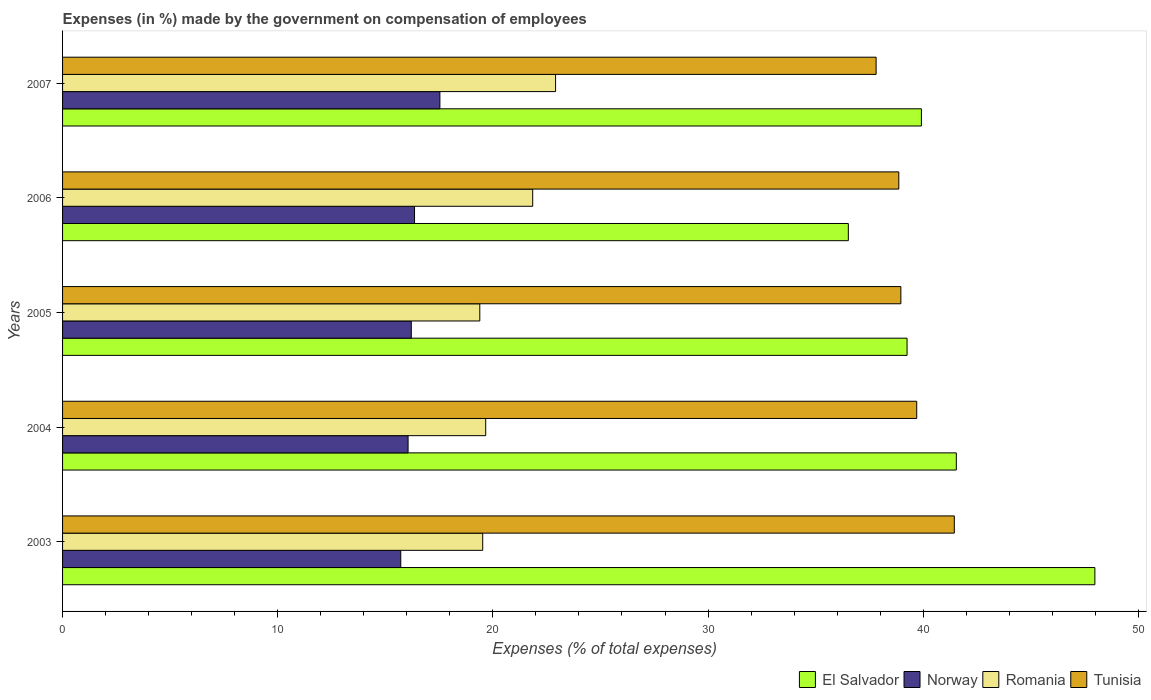Are the number of bars per tick equal to the number of legend labels?
Your answer should be compact. Yes. Are the number of bars on each tick of the Y-axis equal?
Offer a terse response. Yes. What is the percentage of expenses made by the government on compensation of employees in Norway in 2007?
Offer a very short reply. 17.54. Across all years, what is the maximum percentage of expenses made by the government on compensation of employees in Romania?
Make the answer very short. 22.91. Across all years, what is the minimum percentage of expenses made by the government on compensation of employees in El Salvador?
Give a very brief answer. 36.52. What is the total percentage of expenses made by the government on compensation of employees in Tunisia in the graph?
Provide a short and direct response. 196.78. What is the difference between the percentage of expenses made by the government on compensation of employees in Tunisia in 2003 and that in 2007?
Ensure brevity in your answer.  3.63. What is the difference between the percentage of expenses made by the government on compensation of employees in El Salvador in 2007 and the percentage of expenses made by the government on compensation of employees in Romania in 2003?
Your answer should be very brief. 20.39. What is the average percentage of expenses made by the government on compensation of employees in Tunisia per year?
Your answer should be compact. 39.36. In the year 2007, what is the difference between the percentage of expenses made by the government on compensation of employees in Romania and percentage of expenses made by the government on compensation of employees in Tunisia?
Keep it short and to the point. -14.9. In how many years, is the percentage of expenses made by the government on compensation of employees in El Salvador greater than 20 %?
Your answer should be compact. 5. What is the ratio of the percentage of expenses made by the government on compensation of employees in El Salvador in 2003 to that in 2006?
Give a very brief answer. 1.31. Is the difference between the percentage of expenses made by the government on compensation of employees in Romania in 2003 and 2007 greater than the difference between the percentage of expenses made by the government on compensation of employees in Tunisia in 2003 and 2007?
Make the answer very short. No. What is the difference between the highest and the second highest percentage of expenses made by the government on compensation of employees in Romania?
Your response must be concise. 1.06. What is the difference between the highest and the lowest percentage of expenses made by the government on compensation of employees in Romania?
Your response must be concise. 3.52. Is the sum of the percentage of expenses made by the government on compensation of employees in El Salvador in 2004 and 2007 greater than the maximum percentage of expenses made by the government on compensation of employees in Tunisia across all years?
Your response must be concise. Yes. What does the 1st bar from the top in 2003 represents?
Your answer should be compact. Tunisia. What does the 4th bar from the bottom in 2007 represents?
Offer a very short reply. Tunisia. Are the values on the major ticks of X-axis written in scientific E-notation?
Your answer should be very brief. No. Does the graph contain any zero values?
Provide a succinct answer. No. Does the graph contain grids?
Provide a succinct answer. No. Where does the legend appear in the graph?
Provide a succinct answer. Bottom right. How are the legend labels stacked?
Provide a succinct answer. Horizontal. What is the title of the graph?
Keep it short and to the point. Expenses (in %) made by the government on compensation of employees. What is the label or title of the X-axis?
Make the answer very short. Expenses (% of total expenses). What is the Expenses (% of total expenses) in El Salvador in 2003?
Your answer should be compact. 47.98. What is the Expenses (% of total expenses) of Norway in 2003?
Offer a terse response. 15.72. What is the Expenses (% of total expenses) of Romania in 2003?
Offer a very short reply. 19.53. What is the Expenses (% of total expenses) of Tunisia in 2003?
Make the answer very short. 41.44. What is the Expenses (% of total expenses) in El Salvador in 2004?
Your answer should be compact. 41.54. What is the Expenses (% of total expenses) of Norway in 2004?
Your answer should be very brief. 16.06. What is the Expenses (% of total expenses) of Romania in 2004?
Offer a very short reply. 19.67. What is the Expenses (% of total expenses) in Tunisia in 2004?
Make the answer very short. 39.7. What is the Expenses (% of total expenses) in El Salvador in 2005?
Provide a succinct answer. 39.25. What is the Expenses (% of total expenses) of Norway in 2005?
Ensure brevity in your answer.  16.21. What is the Expenses (% of total expenses) in Romania in 2005?
Your answer should be very brief. 19.39. What is the Expenses (% of total expenses) of Tunisia in 2005?
Your answer should be very brief. 38.96. What is the Expenses (% of total expenses) in El Salvador in 2006?
Offer a terse response. 36.52. What is the Expenses (% of total expenses) of Norway in 2006?
Keep it short and to the point. 16.36. What is the Expenses (% of total expenses) in Romania in 2006?
Keep it short and to the point. 21.85. What is the Expenses (% of total expenses) in Tunisia in 2006?
Your answer should be compact. 38.86. What is the Expenses (% of total expenses) in El Salvador in 2007?
Provide a short and direct response. 39.92. What is the Expenses (% of total expenses) of Norway in 2007?
Ensure brevity in your answer.  17.54. What is the Expenses (% of total expenses) of Romania in 2007?
Your answer should be compact. 22.91. What is the Expenses (% of total expenses) of Tunisia in 2007?
Make the answer very short. 37.81. Across all years, what is the maximum Expenses (% of total expenses) in El Salvador?
Keep it short and to the point. 47.98. Across all years, what is the maximum Expenses (% of total expenses) in Norway?
Offer a terse response. 17.54. Across all years, what is the maximum Expenses (% of total expenses) in Romania?
Your answer should be compact. 22.91. Across all years, what is the maximum Expenses (% of total expenses) in Tunisia?
Provide a short and direct response. 41.44. Across all years, what is the minimum Expenses (% of total expenses) of El Salvador?
Your answer should be compact. 36.52. Across all years, what is the minimum Expenses (% of total expenses) in Norway?
Provide a succinct answer. 15.72. Across all years, what is the minimum Expenses (% of total expenses) in Romania?
Keep it short and to the point. 19.39. Across all years, what is the minimum Expenses (% of total expenses) of Tunisia?
Provide a succinct answer. 37.81. What is the total Expenses (% of total expenses) in El Salvador in the graph?
Your answer should be very brief. 205.2. What is the total Expenses (% of total expenses) in Norway in the graph?
Provide a short and direct response. 81.88. What is the total Expenses (% of total expenses) of Romania in the graph?
Your answer should be compact. 103.35. What is the total Expenses (% of total expenses) of Tunisia in the graph?
Make the answer very short. 196.78. What is the difference between the Expenses (% of total expenses) of El Salvador in 2003 and that in 2004?
Your answer should be compact. 6.44. What is the difference between the Expenses (% of total expenses) of Norway in 2003 and that in 2004?
Offer a terse response. -0.34. What is the difference between the Expenses (% of total expenses) of Romania in 2003 and that in 2004?
Give a very brief answer. -0.14. What is the difference between the Expenses (% of total expenses) in Tunisia in 2003 and that in 2004?
Make the answer very short. 1.75. What is the difference between the Expenses (% of total expenses) of El Salvador in 2003 and that in 2005?
Provide a succinct answer. 8.73. What is the difference between the Expenses (% of total expenses) of Norway in 2003 and that in 2005?
Your answer should be compact. -0.49. What is the difference between the Expenses (% of total expenses) of Romania in 2003 and that in 2005?
Ensure brevity in your answer.  0.14. What is the difference between the Expenses (% of total expenses) in Tunisia in 2003 and that in 2005?
Ensure brevity in your answer.  2.48. What is the difference between the Expenses (% of total expenses) of El Salvador in 2003 and that in 2006?
Give a very brief answer. 11.46. What is the difference between the Expenses (% of total expenses) in Norway in 2003 and that in 2006?
Offer a very short reply. -0.64. What is the difference between the Expenses (% of total expenses) of Romania in 2003 and that in 2006?
Provide a short and direct response. -2.32. What is the difference between the Expenses (% of total expenses) of Tunisia in 2003 and that in 2006?
Offer a very short reply. 2.58. What is the difference between the Expenses (% of total expenses) of El Salvador in 2003 and that in 2007?
Provide a succinct answer. 8.06. What is the difference between the Expenses (% of total expenses) of Norway in 2003 and that in 2007?
Your answer should be compact. -1.82. What is the difference between the Expenses (% of total expenses) of Romania in 2003 and that in 2007?
Provide a short and direct response. -3.39. What is the difference between the Expenses (% of total expenses) in Tunisia in 2003 and that in 2007?
Your response must be concise. 3.63. What is the difference between the Expenses (% of total expenses) in El Salvador in 2004 and that in 2005?
Keep it short and to the point. 2.29. What is the difference between the Expenses (% of total expenses) of Norway in 2004 and that in 2005?
Offer a terse response. -0.15. What is the difference between the Expenses (% of total expenses) in Romania in 2004 and that in 2005?
Offer a terse response. 0.27. What is the difference between the Expenses (% of total expenses) of Tunisia in 2004 and that in 2005?
Give a very brief answer. 0.74. What is the difference between the Expenses (% of total expenses) of El Salvador in 2004 and that in 2006?
Ensure brevity in your answer.  5.02. What is the difference between the Expenses (% of total expenses) of Norway in 2004 and that in 2006?
Offer a very short reply. -0.3. What is the difference between the Expenses (% of total expenses) in Romania in 2004 and that in 2006?
Offer a terse response. -2.18. What is the difference between the Expenses (% of total expenses) of Tunisia in 2004 and that in 2006?
Give a very brief answer. 0.83. What is the difference between the Expenses (% of total expenses) of El Salvador in 2004 and that in 2007?
Provide a succinct answer. 1.62. What is the difference between the Expenses (% of total expenses) in Norway in 2004 and that in 2007?
Your answer should be compact. -1.48. What is the difference between the Expenses (% of total expenses) in Romania in 2004 and that in 2007?
Offer a very short reply. -3.25. What is the difference between the Expenses (% of total expenses) in Tunisia in 2004 and that in 2007?
Make the answer very short. 1.89. What is the difference between the Expenses (% of total expenses) of El Salvador in 2005 and that in 2006?
Your response must be concise. 2.73. What is the difference between the Expenses (% of total expenses) in Norway in 2005 and that in 2006?
Keep it short and to the point. -0.15. What is the difference between the Expenses (% of total expenses) of Romania in 2005 and that in 2006?
Ensure brevity in your answer.  -2.46. What is the difference between the Expenses (% of total expenses) in Tunisia in 2005 and that in 2006?
Your answer should be compact. 0.1. What is the difference between the Expenses (% of total expenses) in El Salvador in 2005 and that in 2007?
Provide a short and direct response. -0.67. What is the difference between the Expenses (% of total expenses) in Norway in 2005 and that in 2007?
Ensure brevity in your answer.  -1.33. What is the difference between the Expenses (% of total expenses) of Romania in 2005 and that in 2007?
Your response must be concise. -3.52. What is the difference between the Expenses (% of total expenses) in Tunisia in 2005 and that in 2007?
Give a very brief answer. 1.15. What is the difference between the Expenses (% of total expenses) of El Salvador in 2006 and that in 2007?
Keep it short and to the point. -3.4. What is the difference between the Expenses (% of total expenses) in Norway in 2006 and that in 2007?
Provide a short and direct response. -1.18. What is the difference between the Expenses (% of total expenses) in Romania in 2006 and that in 2007?
Your answer should be compact. -1.06. What is the difference between the Expenses (% of total expenses) of Tunisia in 2006 and that in 2007?
Keep it short and to the point. 1.05. What is the difference between the Expenses (% of total expenses) of El Salvador in 2003 and the Expenses (% of total expenses) of Norway in 2004?
Provide a succinct answer. 31.92. What is the difference between the Expenses (% of total expenses) in El Salvador in 2003 and the Expenses (% of total expenses) in Romania in 2004?
Your response must be concise. 28.31. What is the difference between the Expenses (% of total expenses) of El Salvador in 2003 and the Expenses (% of total expenses) of Tunisia in 2004?
Offer a terse response. 8.28. What is the difference between the Expenses (% of total expenses) in Norway in 2003 and the Expenses (% of total expenses) in Romania in 2004?
Your answer should be compact. -3.95. What is the difference between the Expenses (% of total expenses) in Norway in 2003 and the Expenses (% of total expenses) in Tunisia in 2004?
Provide a short and direct response. -23.98. What is the difference between the Expenses (% of total expenses) of Romania in 2003 and the Expenses (% of total expenses) of Tunisia in 2004?
Your answer should be very brief. -20.17. What is the difference between the Expenses (% of total expenses) of El Salvador in 2003 and the Expenses (% of total expenses) of Norway in 2005?
Provide a short and direct response. 31.77. What is the difference between the Expenses (% of total expenses) of El Salvador in 2003 and the Expenses (% of total expenses) of Romania in 2005?
Your response must be concise. 28.59. What is the difference between the Expenses (% of total expenses) of El Salvador in 2003 and the Expenses (% of total expenses) of Tunisia in 2005?
Provide a short and direct response. 9.02. What is the difference between the Expenses (% of total expenses) of Norway in 2003 and the Expenses (% of total expenses) of Romania in 2005?
Your answer should be compact. -3.67. What is the difference between the Expenses (% of total expenses) of Norway in 2003 and the Expenses (% of total expenses) of Tunisia in 2005?
Make the answer very short. -23.24. What is the difference between the Expenses (% of total expenses) of Romania in 2003 and the Expenses (% of total expenses) of Tunisia in 2005?
Give a very brief answer. -19.43. What is the difference between the Expenses (% of total expenses) in El Salvador in 2003 and the Expenses (% of total expenses) in Norway in 2006?
Ensure brevity in your answer.  31.62. What is the difference between the Expenses (% of total expenses) of El Salvador in 2003 and the Expenses (% of total expenses) of Romania in 2006?
Offer a terse response. 26.13. What is the difference between the Expenses (% of total expenses) of El Salvador in 2003 and the Expenses (% of total expenses) of Tunisia in 2006?
Offer a terse response. 9.11. What is the difference between the Expenses (% of total expenses) in Norway in 2003 and the Expenses (% of total expenses) in Romania in 2006?
Offer a very short reply. -6.13. What is the difference between the Expenses (% of total expenses) in Norway in 2003 and the Expenses (% of total expenses) in Tunisia in 2006?
Provide a short and direct response. -23.15. What is the difference between the Expenses (% of total expenses) of Romania in 2003 and the Expenses (% of total expenses) of Tunisia in 2006?
Provide a succinct answer. -19.34. What is the difference between the Expenses (% of total expenses) of El Salvador in 2003 and the Expenses (% of total expenses) of Norway in 2007?
Ensure brevity in your answer.  30.44. What is the difference between the Expenses (% of total expenses) in El Salvador in 2003 and the Expenses (% of total expenses) in Romania in 2007?
Your answer should be very brief. 25.06. What is the difference between the Expenses (% of total expenses) of El Salvador in 2003 and the Expenses (% of total expenses) of Tunisia in 2007?
Your response must be concise. 10.17. What is the difference between the Expenses (% of total expenses) in Norway in 2003 and the Expenses (% of total expenses) in Romania in 2007?
Make the answer very short. -7.2. What is the difference between the Expenses (% of total expenses) in Norway in 2003 and the Expenses (% of total expenses) in Tunisia in 2007?
Give a very brief answer. -22.09. What is the difference between the Expenses (% of total expenses) of Romania in 2003 and the Expenses (% of total expenses) of Tunisia in 2007?
Provide a short and direct response. -18.28. What is the difference between the Expenses (% of total expenses) in El Salvador in 2004 and the Expenses (% of total expenses) in Norway in 2005?
Provide a succinct answer. 25.33. What is the difference between the Expenses (% of total expenses) of El Salvador in 2004 and the Expenses (% of total expenses) of Romania in 2005?
Provide a succinct answer. 22.15. What is the difference between the Expenses (% of total expenses) in El Salvador in 2004 and the Expenses (% of total expenses) in Tunisia in 2005?
Offer a terse response. 2.58. What is the difference between the Expenses (% of total expenses) of Norway in 2004 and the Expenses (% of total expenses) of Romania in 2005?
Offer a very short reply. -3.33. What is the difference between the Expenses (% of total expenses) in Norway in 2004 and the Expenses (% of total expenses) in Tunisia in 2005?
Provide a short and direct response. -22.9. What is the difference between the Expenses (% of total expenses) of Romania in 2004 and the Expenses (% of total expenses) of Tunisia in 2005?
Offer a very short reply. -19.29. What is the difference between the Expenses (% of total expenses) of El Salvador in 2004 and the Expenses (% of total expenses) of Norway in 2006?
Your response must be concise. 25.18. What is the difference between the Expenses (% of total expenses) in El Salvador in 2004 and the Expenses (% of total expenses) in Romania in 2006?
Ensure brevity in your answer.  19.69. What is the difference between the Expenses (% of total expenses) in El Salvador in 2004 and the Expenses (% of total expenses) in Tunisia in 2006?
Your answer should be very brief. 2.67. What is the difference between the Expenses (% of total expenses) in Norway in 2004 and the Expenses (% of total expenses) in Romania in 2006?
Provide a short and direct response. -5.79. What is the difference between the Expenses (% of total expenses) in Norway in 2004 and the Expenses (% of total expenses) in Tunisia in 2006?
Keep it short and to the point. -22.81. What is the difference between the Expenses (% of total expenses) of Romania in 2004 and the Expenses (% of total expenses) of Tunisia in 2006?
Your answer should be very brief. -19.2. What is the difference between the Expenses (% of total expenses) in El Salvador in 2004 and the Expenses (% of total expenses) in Norway in 2007?
Your answer should be compact. 24. What is the difference between the Expenses (% of total expenses) in El Salvador in 2004 and the Expenses (% of total expenses) in Romania in 2007?
Your answer should be very brief. 18.62. What is the difference between the Expenses (% of total expenses) in El Salvador in 2004 and the Expenses (% of total expenses) in Tunisia in 2007?
Give a very brief answer. 3.73. What is the difference between the Expenses (% of total expenses) in Norway in 2004 and the Expenses (% of total expenses) in Romania in 2007?
Provide a succinct answer. -6.85. What is the difference between the Expenses (% of total expenses) in Norway in 2004 and the Expenses (% of total expenses) in Tunisia in 2007?
Offer a terse response. -21.75. What is the difference between the Expenses (% of total expenses) of Romania in 2004 and the Expenses (% of total expenses) of Tunisia in 2007?
Keep it short and to the point. -18.14. What is the difference between the Expenses (% of total expenses) in El Salvador in 2005 and the Expenses (% of total expenses) in Norway in 2006?
Provide a short and direct response. 22.89. What is the difference between the Expenses (% of total expenses) in El Salvador in 2005 and the Expenses (% of total expenses) in Romania in 2006?
Offer a terse response. 17.4. What is the difference between the Expenses (% of total expenses) of El Salvador in 2005 and the Expenses (% of total expenses) of Tunisia in 2006?
Your answer should be very brief. 0.38. What is the difference between the Expenses (% of total expenses) in Norway in 2005 and the Expenses (% of total expenses) in Romania in 2006?
Provide a short and direct response. -5.64. What is the difference between the Expenses (% of total expenses) of Norway in 2005 and the Expenses (% of total expenses) of Tunisia in 2006?
Make the answer very short. -22.66. What is the difference between the Expenses (% of total expenses) in Romania in 2005 and the Expenses (% of total expenses) in Tunisia in 2006?
Keep it short and to the point. -19.47. What is the difference between the Expenses (% of total expenses) of El Salvador in 2005 and the Expenses (% of total expenses) of Norway in 2007?
Keep it short and to the point. 21.71. What is the difference between the Expenses (% of total expenses) of El Salvador in 2005 and the Expenses (% of total expenses) of Romania in 2007?
Your answer should be very brief. 16.34. What is the difference between the Expenses (% of total expenses) of El Salvador in 2005 and the Expenses (% of total expenses) of Tunisia in 2007?
Offer a very short reply. 1.44. What is the difference between the Expenses (% of total expenses) in Norway in 2005 and the Expenses (% of total expenses) in Romania in 2007?
Ensure brevity in your answer.  -6.71. What is the difference between the Expenses (% of total expenses) in Norway in 2005 and the Expenses (% of total expenses) in Tunisia in 2007?
Ensure brevity in your answer.  -21.6. What is the difference between the Expenses (% of total expenses) of Romania in 2005 and the Expenses (% of total expenses) of Tunisia in 2007?
Your answer should be compact. -18.42. What is the difference between the Expenses (% of total expenses) in El Salvador in 2006 and the Expenses (% of total expenses) in Norway in 2007?
Offer a terse response. 18.98. What is the difference between the Expenses (% of total expenses) in El Salvador in 2006 and the Expenses (% of total expenses) in Romania in 2007?
Provide a succinct answer. 13.61. What is the difference between the Expenses (% of total expenses) in El Salvador in 2006 and the Expenses (% of total expenses) in Tunisia in 2007?
Provide a short and direct response. -1.29. What is the difference between the Expenses (% of total expenses) of Norway in 2006 and the Expenses (% of total expenses) of Romania in 2007?
Offer a terse response. -6.56. What is the difference between the Expenses (% of total expenses) of Norway in 2006 and the Expenses (% of total expenses) of Tunisia in 2007?
Offer a very short reply. -21.45. What is the difference between the Expenses (% of total expenses) in Romania in 2006 and the Expenses (% of total expenses) in Tunisia in 2007?
Give a very brief answer. -15.96. What is the average Expenses (% of total expenses) of El Salvador per year?
Your answer should be compact. 41.04. What is the average Expenses (% of total expenses) in Norway per year?
Ensure brevity in your answer.  16.38. What is the average Expenses (% of total expenses) in Romania per year?
Offer a terse response. 20.67. What is the average Expenses (% of total expenses) in Tunisia per year?
Provide a succinct answer. 39.36. In the year 2003, what is the difference between the Expenses (% of total expenses) of El Salvador and Expenses (% of total expenses) of Norway?
Keep it short and to the point. 32.26. In the year 2003, what is the difference between the Expenses (% of total expenses) of El Salvador and Expenses (% of total expenses) of Romania?
Ensure brevity in your answer.  28.45. In the year 2003, what is the difference between the Expenses (% of total expenses) of El Salvador and Expenses (% of total expenses) of Tunisia?
Make the answer very short. 6.53. In the year 2003, what is the difference between the Expenses (% of total expenses) in Norway and Expenses (% of total expenses) in Romania?
Provide a succinct answer. -3.81. In the year 2003, what is the difference between the Expenses (% of total expenses) of Norway and Expenses (% of total expenses) of Tunisia?
Provide a short and direct response. -25.73. In the year 2003, what is the difference between the Expenses (% of total expenses) in Romania and Expenses (% of total expenses) in Tunisia?
Offer a very short reply. -21.92. In the year 2004, what is the difference between the Expenses (% of total expenses) of El Salvador and Expenses (% of total expenses) of Norway?
Offer a terse response. 25.48. In the year 2004, what is the difference between the Expenses (% of total expenses) of El Salvador and Expenses (% of total expenses) of Romania?
Give a very brief answer. 21.87. In the year 2004, what is the difference between the Expenses (% of total expenses) in El Salvador and Expenses (% of total expenses) in Tunisia?
Your answer should be compact. 1.84. In the year 2004, what is the difference between the Expenses (% of total expenses) of Norway and Expenses (% of total expenses) of Romania?
Your answer should be very brief. -3.61. In the year 2004, what is the difference between the Expenses (% of total expenses) in Norway and Expenses (% of total expenses) in Tunisia?
Keep it short and to the point. -23.64. In the year 2004, what is the difference between the Expenses (% of total expenses) in Romania and Expenses (% of total expenses) in Tunisia?
Your response must be concise. -20.03. In the year 2005, what is the difference between the Expenses (% of total expenses) in El Salvador and Expenses (% of total expenses) in Norway?
Your answer should be very brief. 23.04. In the year 2005, what is the difference between the Expenses (% of total expenses) of El Salvador and Expenses (% of total expenses) of Romania?
Your answer should be very brief. 19.86. In the year 2005, what is the difference between the Expenses (% of total expenses) in El Salvador and Expenses (% of total expenses) in Tunisia?
Ensure brevity in your answer.  0.29. In the year 2005, what is the difference between the Expenses (% of total expenses) of Norway and Expenses (% of total expenses) of Romania?
Your response must be concise. -3.18. In the year 2005, what is the difference between the Expenses (% of total expenses) in Norway and Expenses (% of total expenses) in Tunisia?
Ensure brevity in your answer.  -22.75. In the year 2005, what is the difference between the Expenses (% of total expenses) in Romania and Expenses (% of total expenses) in Tunisia?
Give a very brief answer. -19.57. In the year 2006, what is the difference between the Expenses (% of total expenses) in El Salvador and Expenses (% of total expenses) in Norway?
Keep it short and to the point. 20.16. In the year 2006, what is the difference between the Expenses (% of total expenses) of El Salvador and Expenses (% of total expenses) of Romania?
Your response must be concise. 14.67. In the year 2006, what is the difference between the Expenses (% of total expenses) in El Salvador and Expenses (% of total expenses) in Tunisia?
Your answer should be compact. -2.35. In the year 2006, what is the difference between the Expenses (% of total expenses) of Norway and Expenses (% of total expenses) of Romania?
Your response must be concise. -5.49. In the year 2006, what is the difference between the Expenses (% of total expenses) in Norway and Expenses (% of total expenses) in Tunisia?
Make the answer very short. -22.51. In the year 2006, what is the difference between the Expenses (% of total expenses) of Romania and Expenses (% of total expenses) of Tunisia?
Offer a very short reply. -17.01. In the year 2007, what is the difference between the Expenses (% of total expenses) in El Salvador and Expenses (% of total expenses) in Norway?
Provide a succinct answer. 22.38. In the year 2007, what is the difference between the Expenses (% of total expenses) of El Salvador and Expenses (% of total expenses) of Romania?
Your response must be concise. 17. In the year 2007, what is the difference between the Expenses (% of total expenses) in El Salvador and Expenses (% of total expenses) in Tunisia?
Your answer should be compact. 2.11. In the year 2007, what is the difference between the Expenses (% of total expenses) of Norway and Expenses (% of total expenses) of Romania?
Offer a terse response. -5.38. In the year 2007, what is the difference between the Expenses (% of total expenses) in Norway and Expenses (% of total expenses) in Tunisia?
Your response must be concise. -20.27. In the year 2007, what is the difference between the Expenses (% of total expenses) in Romania and Expenses (% of total expenses) in Tunisia?
Ensure brevity in your answer.  -14.9. What is the ratio of the Expenses (% of total expenses) of El Salvador in 2003 to that in 2004?
Provide a short and direct response. 1.16. What is the ratio of the Expenses (% of total expenses) of Norway in 2003 to that in 2004?
Your response must be concise. 0.98. What is the ratio of the Expenses (% of total expenses) in Romania in 2003 to that in 2004?
Provide a succinct answer. 0.99. What is the ratio of the Expenses (% of total expenses) of Tunisia in 2003 to that in 2004?
Provide a short and direct response. 1.04. What is the ratio of the Expenses (% of total expenses) in El Salvador in 2003 to that in 2005?
Make the answer very short. 1.22. What is the ratio of the Expenses (% of total expenses) in Norway in 2003 to that in 2005?
Offer a terse response. 0.97. What is the ratio of the Expenses (% of total expenses) of Tunisia in 2003 to that in 2005?
Your answer should be compact. 1.06. What is the ratio of the Expenses (% of total expenses) of El Salvador in 2003 to that in 2006?
Give a very brief answer. 1.31. What is the ratio of the Expenses (% of total expenses) in Norway in 2003 to that in 2006?
Your answer should be very brief. 0.96. What is the ratio of the Expenses (% of total expenses) of Romania in 2003 to that in 2006?
Keep it short and to the point. 0.89. What is the ratio of the Expenses (% of total expenses) of Tunisia in 2003 to that in 2006?
Your response must be concise. 1.07. What is the ratio of the Expenses (% of total expenses) in El Salvador in 2003 to that in 2007?
Your response must be concise. 1.2. What is the ratio of the Expenses (% of total expenses) of Norway in 2003 to that in 2007?
Keep it short and to the point. 0.9. What is the ratio of the Expenses (% of total expenses) of Romania in 2003 to that in 2007?
Your answer should be very brief. 0.85. What is the ratio of the Expenses (% of total expenses) in Tunisia in 2003 to that in 2007?
Offer a very short reply. 1.1. What is the ratio of the Expenses (% of total expenses) of El Salvador in 2004 to that in 2005?
Your answer should be compact. 1.06. What is the ratio of the Expenses (% of total expenses) of Romania in 2004 to that in 2005?
Offer a very short reply. 1.01. What is the ratio of the Expenses (% of total expenses) of Tunisia in 2004 to that in 2005?
Keep it short and to the point. 1.02. What is the ratio of the Expenses (% of total expenses) in El Salvador in 2004 to that in 2006?
Give a very brief answer. 1.14. What is the ratio of the Expenses (% of total expenses) of Norway in 2004 to that in 2006?
Provide a short and direct response. 0.98. What is the ratio of the Expenses (% of total expenses) in Tunisia in 2004 to that in 2006?
Ensure brevity in your answer.  1.02. What is the ratio of the Expenses (% of total expenses) in El Salvador in 2004 to that in 2007?
Your answer should be compact. 1.04. What is the ratio of the Expenses (% of total expenses) of Norway in 2004 to that in 2007?
Offer a terse response. 0.92. What is the ratio of the Expenses (% of total expenses) in Romania in 2004 to that in 2007?
Keep it short and to the point. 0.86. What is the ratio of the Expenses (% of total expenses) of Tunisia in 2004 to that in 2007?
Keep it short and to the point. 1.05. What is the ratio of the Expenses (% of total expenses) in El Salvador in 2005 to that in 2006?
Offer a very short reply. 1.07. What is the ratio of the Expenses (% of total expenses) of Romania in 2005 to that in 2006?
Offer a very short reply. 0.89. What is the ratio of the Expenses (% of total expenses) of El Salvador in 2005 to that in 2007?
Provide a succinct answer. 0.98. What is the ratio of the Expenses (% of total expenses) in Norway in 2005 to that in 2007?
Keep it short and to the point. 0.92. What is the ratio of the Expenses (% of total expenses) of Romania in 2005 to that in 2007?
Provide a short and direct response. 0.85. What is the ratio of the Expenses (% of total expenses) in Tunisia in 2005 to that in 2007?
Your answer should be very brief. 1.03. What is the ratio of the Expenses (% of total expenses) in El Salvador in 2006 to that in 2007?
Offer a terse response. 0.91. What is the ratio of the Expenses (% of total expenses) in Norway in 2006 to that in 2007?
Provide a succinct answer. 0.93. What is the ratio of the Expenses (% of total expenses) of Romania in 2006 to that in 2007?
Ensure brevity in your answer.  0.95. What is the ratio of the Expenses (% of total expenses) of Tunisia in 2006 to that in 2007?
Offer a very short reply. 1.03. What is the difference between the highest and the second highest Expenses (% of total expenses) of El Salvador?
Give a very brief answer. 6.44. What is the difference between the highest and the second highest Expenses (% of total expenses) of Norway?
Offer a terse response. 1.18. What is the difference between the highest and the second highest Expenses (% of total expenses) in Romania?
Ensure brevity in your answer.  1.06. What is the difference between the highest and the second highest Expenses (% of total expenses) of Tunisia?
Ensure brevity in your answer.  1.75. What is the difference between the highest and the lowest Expenses (% of total expenses) in El Salvador?
Your response must be concise. 11.46. What is the difference between the highest and the lowest Expenses (% of total expenses) in Norway?
Provide a succinct answer. 1.82. What is the difference between the highest and the lowest Expenses (% of total expenses) of Romania?
Offer a very short reply. 3.52. What is the difference between the highest and the lowest Expenses (% of total expenses) in Tunisia?
Make the answer very short. 3.63. 